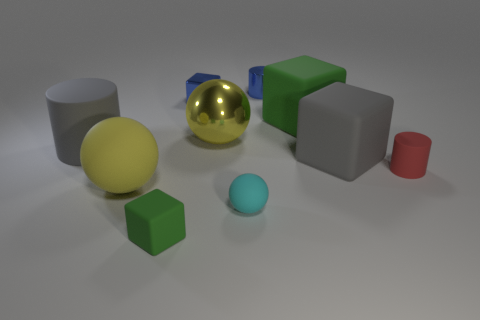There is a tiny cylinder that is on the left side of the small object on the right side of the big green rubber object; what number of big gray rubber objects are to the left of it?
Ensure brevity in your answer.  1. There is a small matte cube; does it have the same color as the matte block that is behind the gray cube?
Make the answer very short. Yes. There is a big rubber thing that is the same color as the large metal ball; what is its shape?
Your answer should be very brief. Sphere. What material is the tiny green cube that is right of the big yellow sphere that is on the left side of the tiny cube that is behind the cyan object?
Offer a terse response. Rubber. There is a yellow object that is in front of the tiny red matte object; is it the same shape as the tiny cyan object?
Make the answer very short. Yes. What is the large gray thing that is on the right side of the large metallic ball made of?
Keep it short and to the point. Rubber. How many rubber objects are big gray cylinders or large green blocks?
Offer a terse response. 2. Is there a yellow thing of the same size as the gray rubber block?
Keep it short and to the point. Yes. Are there more yellow balls behind the big gray cylinder than tiny rubber objects?
Your response must be concise. No. What number of small things are either yellow balls or cyan objects?
Offer a very short reply. 1. 